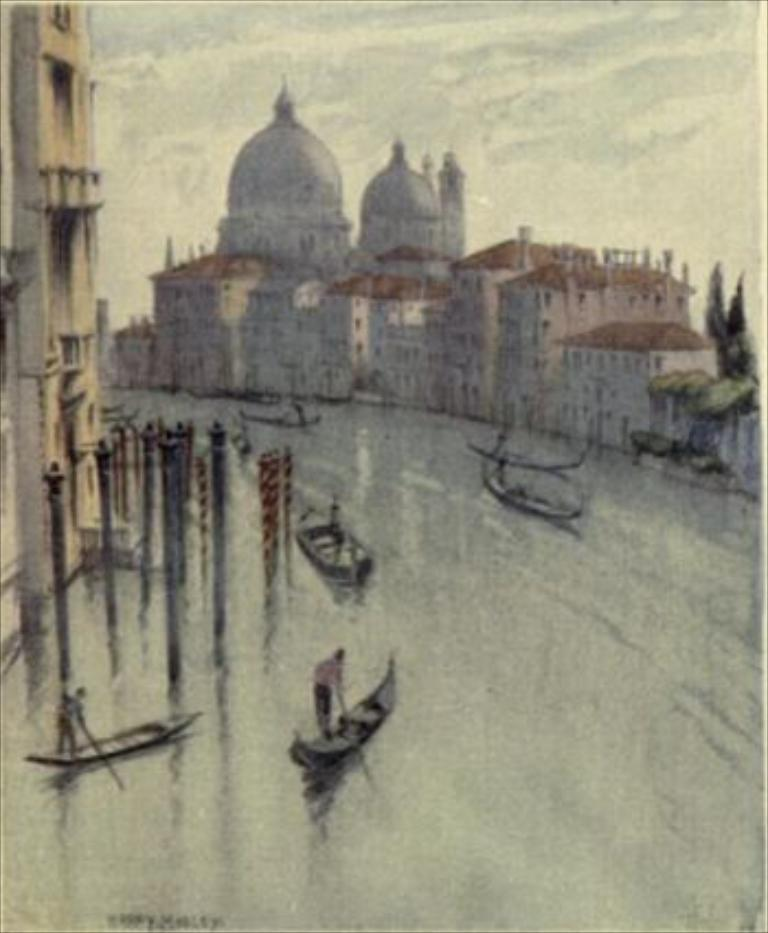What is the main subject of the image? The main subject of the image is a river. What is happening in the river? There are boats sailing in the river. Are there any structures visible near the river? Yes, there are buildings visible near the river. How many buckets of rainwater can be seen during the rainstorm in the image? There is no rainstorm depicted in the image, and therefore no buckets of rainwater can be seen. 